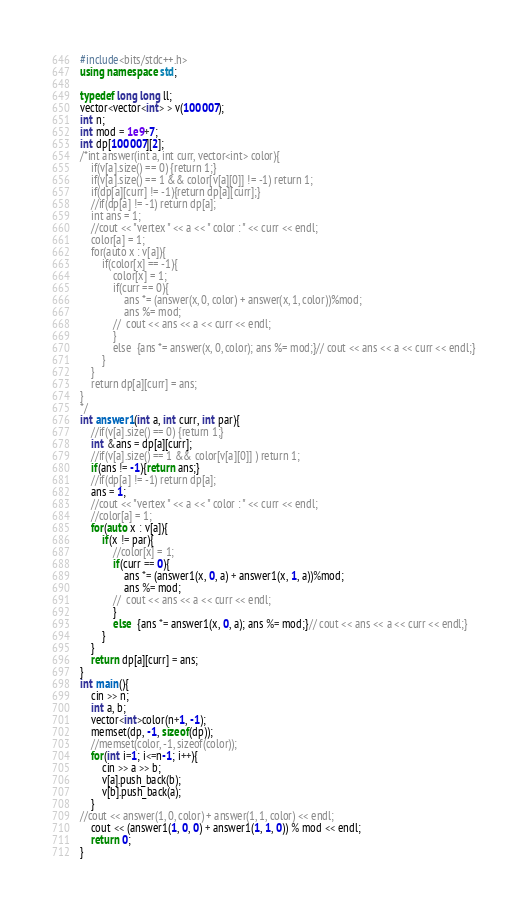Convert code to text. <code><loc_0><loc_0><loc_500><loc_500><_C++_>#include<bits/stdc++.h>
using namespace std;

typedef long long ll;
vector<vector<int> > v(100007);
int n;
int mod = 1e9+7;
int dp[100007][2];
/*int answer(int a, int curr, vector<int> color){
	if(v[a].size() == 0) {return 1;}
	if(v[a].size() == 1 && color[v[a][0]] != -1) return 1;
	if(dp[a][curr] != -1){return dp[a][curr];}
	//if(dp[a] != -1) return dp[a];
	int ans = 1;
	//cout << "vertex " << a << " color : " << curr << endl;
	color[a] = 1;
	for(auto x : v[a]){
		if(color[x] == -1){
			color[x] = 1;
			if(curr == 0){
				ans *= (answer(x, 0, color) + answer(x, 1, color))%mod;
				ans %= mod;
			//	cout << ans << a << curr << endl;
			}
			else  {ans *= answer(x, 0, color); ans %= mod;}// cout << ans << a << curr << endl;}
		}
	}
	return dp[a][curr] = ans;
}
*/
int answer1(int a, int curr, int par){
	//if(v[a].size() == 0) {return 1;}
	int &ans = dp[a][curr];
	//if(v[a].size() == 1 && color[v[a][0]] ) return 1;
	if(ans != -1){return ans;}
	//if(dp[a] != -1) return dp[a];
	ans = 1;
	//cout << "vertex " << a << " color : " << curr << endl;
	//color[a] = 1;
	for(auto x : v[a]){
		if(x != par){
			//color[x] = 1;
			if(curr == 0){
				ans *= (answer1(x, 0, a) + answer1(x, 1, a))%mod;
				ans %= mod;
			//	cout << ans << a << curr << endl;
			}
			else  {ans *= answer1(x, 0, a); ans %= mod;}// cout << ans << a << curr << endl;}
		}
	}
	return dp[a][curr] = ans;
}
int main(){
	cin >> n;
	int a, b;
	vector<int>color(n+1, -1);
	memset(dp, -1, sizeof(dp));
	//memset(color, -1, sizeof(color));
	for(int i=1; i<=n-1; i++){
		cin >> a >> b;
		v[a].push_back(b);
		v[b].push_back(a);
	}
//cout << answer(1, 0, color) + answer(1, 1, color) << endl;
	cout << (answer1(1, 0, 0) + answer1(1, 1, 0)) % mod << endl;
	return 0;
}

</code> 